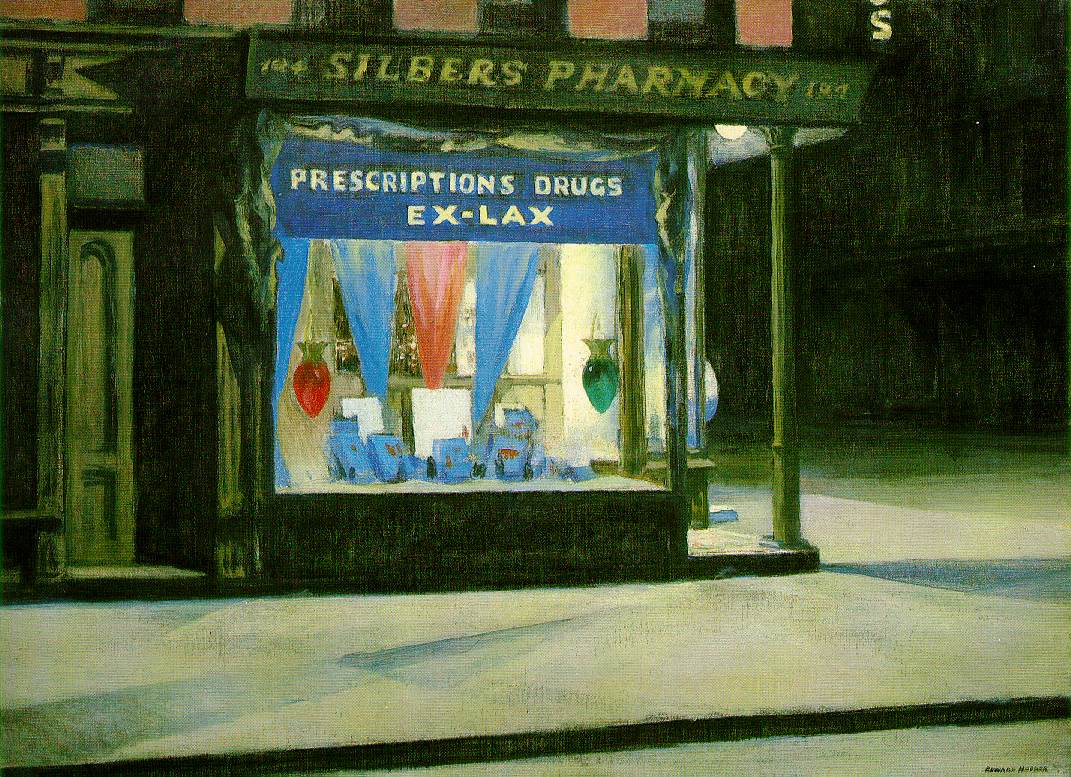Describe the following image. The image portrays 'Silber's Pharmacy' at night, rendered in a style reminiscent of American realism. This art movement emphasizes a naturalistic representation of everyday scenes, which is evident in the meticulous depiction of the pharmacy's façade and its surroundings. The muted color palette underscores the nocturnal setting, creating a subdued ambient mood contrasted sharply by the pharmacy window's vibrant display of blue and red hues. Notably, the pharmacy sign indicating 'Prescriptions Drugs Ex-Lax' suggests its role within the community as a provider of essential services. The absence of human figures adds a layer of solitude and quietness, inviting viewers to ponder the urban life's quieter, often overlooked moments. Enhancing this observation, one might consider the economic and social implications of such a setting during the era depicted, possibly pointing to the broader socioeconomic conditions of the time and their impact on daily life and business operations in urban locales. 